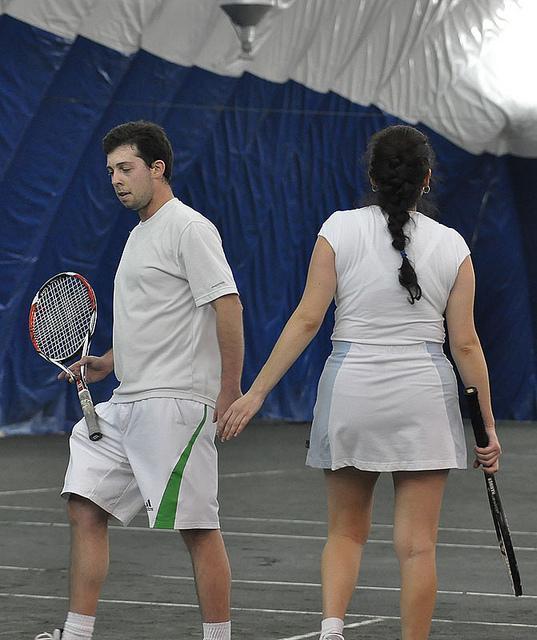What is making the man's pocket pop up?
Answer the question by selecting the correct answer among the 4 following choices and explain your choice with a short sentence. The answer should be formatted with the following format: `Answer: choice
Rationale: rationale.`
Options: Billiard balls, meat balls, bouncy balls, tennis balls. Answer: tennis balls.
Rationale: They are playing tennis. 